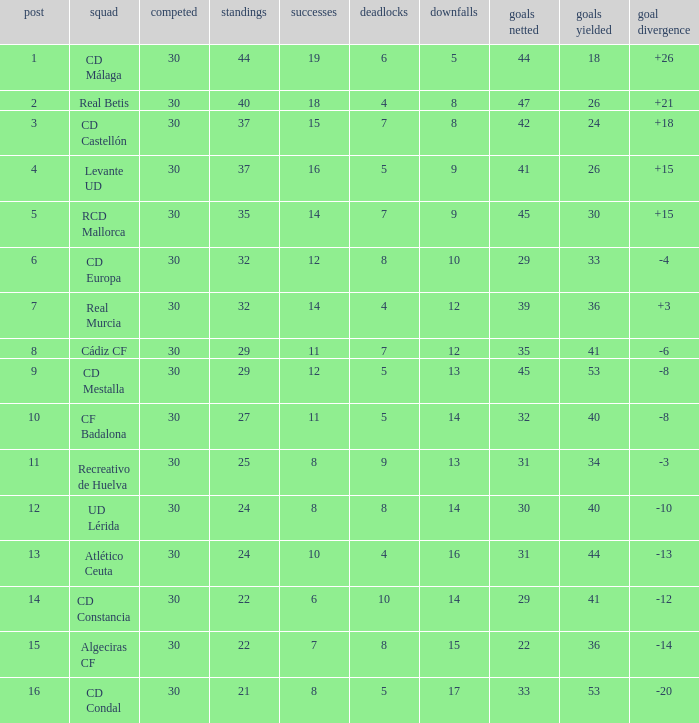What is the goals for when played is larger than 30? None. 